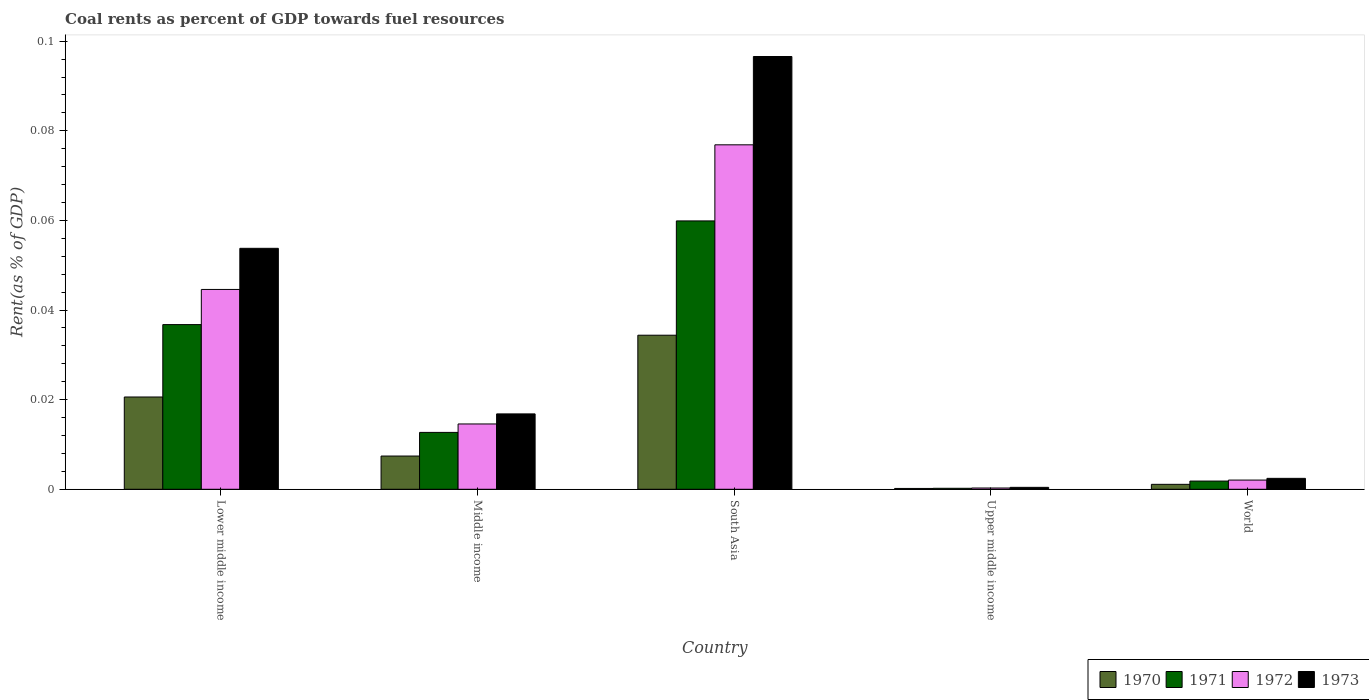How many different coloured bars are there?
Your answer should be very brief. 4. How many groups of bars are there?
Provide a succinct answer. 5. Are the number of bars per tick equal to the number of legend labels?
Offer a terse response. Yes. How many bars are there on the 4th tick from the right?
Make the answer very short. 4. What is the coal rent in 1972 in South Asia?
Provide a succinct answer. 0.08. Across all countries, what is the maximum coal rent in 1973?
Offer a very short reply. 0.1. Across all countries, what is the minimum coal rent in 1970?
Offer a terse response. 0. In which country was the coal rent in 1971 minimum?
Provide a succinct answer. Upper middle income. What is the total coal rent in 1971 in the graph?
Ensure brevity in your answer.  0.11. What is the difference between the coal rent in 1970 in Middle income and that in World?
Your answer should be compact. 0.01. What is the difference between the coal rent in 1971 in Upper middle income and the coal rent in 1973 in South Asia?
Provide a short and direct response. -0.1. What is the average coal rent in 1972 per country?
Offer a very short reply. 0.03. What is the difference between the coal rent of/in 1972 and coal rent of/in 1973 in Lower middle income?
Make the answer very short. -0.01. In how many countries, is the coal rent in 1973 greater than 0.08 %?
Make the answer very short. 1. What is the ratio of the coal rent in 1973 in Upper middle income to that in World?
Ensure brevity in your answer.  0.18. Is the coal rent in 1971 in Lower middle income less than that in Middle income?
Your answer should be very brief. No. What is the difference between the highest and the second highest coal rent in 1970?
Offer a very short reply. 0.01. What is the difference between the highest and the lowest coal rent in 1972?
Your answer should be very brief. 0.08. In how many countries, is the coal rent in 1970 greater than the average coal rent in 1970 taken over all countries?
Give a very brief answer. 2. Is it the case that in every country, the sum of the coal rent in 1971 and coal rent in 1973 is greater than the sum of coal rent in 1970 and coal rent in 1972?
Give a very brief answer. No. What does the 1st bar from the left in Lower middle income represents?
Keep it short and to the point. 1970. What does the 1st bar from the right in Upper middle income represents?
Your response must be concise. 1973. Where does the legend appear in the graph?
Provide a succinct answer. Bottom right. How many legend labels are there?
Keep it short and to the point. 4. What is the title of the graph?
Your answer should be very brief. Coal rents as percent of GDP towards fuel resources. Does "2003" appear as one of the legend labels in the graph?
Ensure brevity in your answer.  No. What is the label or title of the Y-axis?
Give a very brief answer. Rent(as % of GDP). What is the Rent(as % of GDP) in 1970 in Lower middle income?
Keep it short and to the point. 0.02. What is the Rent(as % of GDP) in 1971 in Lower middle income?
Provide a short and direct response. 0.04. What is the Rent(as % of GDP) in 1972 in Lower middle income?
Offer a very short reply. 0.04. What is the Rent(as % of GDP) in 1973 in Lower middle income?
Offer a very short reply. 0.05. What is the Rent(as % of GDP) in 1970 in Middle income?
Offer a very short reply. 0.01. What is the Rent(as % of GDP) in 1971 in Middle income?
Keep it short and to the point. 0.01. What is the Rent(as % of GDP) of 1972 in Middle income?
Keep it short and to the point. 0.01. What is the Rent(as % of GDP) in 1973 in Middle income?
Your answer should be compact. 0.02. What is the Rent(as % of GDP) of 1970 in South Asia?
Your answer should be compact. 0.03. What is the Rent(as % of GDP) of 1971 in South Asia?
Offer a terse response. 0.06. What is the Rent(as % of GDP) of 1972 in South Asia?
Give a very brief answer. 0.08. What is the Rent(as % of GDP) in 1973 in South Asia?
Make the answer very short. 0.1. What is the Rent(as % of GDP) in 1970 in Upper middle income?
Your response must be concise. 0. What is the Rent(as % of GDP) in 1971 in Upper middle income?
Offer a very short reply. 0. What is the Rent(as % of GDP) of 1972 in Upper middle income?
Provide a short and direct response. 0. What is the Rent(as % of GDP) of 1973 in Upper middle income?
Your answer should be very brief. 0. What is the Rent(as % of GDP) of 1970 in World?
Offer a very short reply. 0. What is the Rent(as % of GDP) in 1971 in World?
Your response must be concise. 0. What is the Rent(as % of GDP) in 1972 in World?
Make the answer very short. 0. What is the Rent(as % of GDP) of 1973 in World?
Offer a terse response. 0. Across all countries, what is the maximum Rent(as % of GDP) of 1970?
Your answer should be very brief. 0.03. Across all countries, what is the maximum Rent(as % of GDP) in 1971?
Ensure brevity in your answer.  0.06. Across all countries, what is the maximum Rent(as % of GDP) of 1972?
Offer a very short reply. 0.08. Across all countries, what is the maximum Rent(as % of GDP) in 1973?
Make the answer very short. 0.1. Across all countries, what is the minimum Rent(as % of GDP) in 1970?
Keep it short and to the point. 0. Across all countries, what is the minimum Rent(as % of GDP) of 1971?
Provide a short and direct response. 0. Across all countries, what is the minimum Rent(as % of GDP) of 1972?
Provide a short and direct response. 0. Across all countries, what is the minimum Rent(as % of GDP) in 1973?
Your answer should be compact. 0. What is the total Rent(as % of GDP) of 1970 in the graph?
Make the answer very short. 0.06. What is the total Rent(as % of GDP) in 1971 in the graph?
Offer a terse response. 0.11. What is the total Rent(as % of GDP) of 1972 in the graph?
Keep it short and to the point. 0.14. What is the total Rent(as % of GDP) of 1973 in the graph?
Your answer should be compact. 0.17. What is the difference between the Rent(as % of GDP) of 1970 in Lower middle income and that in Middle income?
Your answer should be very brief. 0.01. What is the difference between the Rent(as % of GDP) in 1971 in Lower middle income and that in Middle income?
Offer a very short reply. 0.02. What is the difference between the Rent(as % of GDP) of 1973 in Lower middle income and that in Middle income?
Keep it short and to the point. 0.04. What is the difference between the Rent(as % of GDP) of 1970 in Lower middle income and that in South Asia?
Your answer should be compact. -0.01. What is the difference between the Rent(as % of GDP) in 1971 in Lower middle income and that in South Asia?
Your answer should be very brief. -0.02. What is the difference between the Rent(as % of GDP) of 1972 in Lower middle income and that in South Asia?
Your answer should be compact. -0.03. What is the difference between the Rent(as % of GDP) in 1973 in Lower middle income and that in South Asia?
Offer a terse response. -0.04. What is the difference between the Rent(as % of GDP) in 1970 in Lower middle income and that in Upper middle income?
Ensure brevity in your answer.  0.02. What is the difference between the Rent(as % of GDP) in 1971 in Lower middle income and that in Upper middle income?
Ensure brevity in your answer.  0.04. What is the difference between the Rent(as % of GDP) in 1972 in Lower middle income and that in Upper middle income?
Offer a very short reply. 0.04. What is the difference between the Rent(as % of GDP) in 1973 in Lower middle income and that in Upper middle income?
Make the answer very short. 0.05. What is the difference between the Rent(as % of GDP) in 1970 in Lower middle income and that in World?
Your response must be concise. 0.02. What is the difference between the Rent(as % of GDP) of 1971 in Lower middle income and that in World?
Your answer should be very brief. 0.03. What is the difference between the Rent(as % of GDP) of 1972 in Lower middle income and that in World?
Offer a very short reply. 0.04. What is the difference between the Rent(as % of GDP) of 1973 in Lower middle income and that in World?
Offer a very short reply. 0.05. What is the difference between the Rent(as % of GDP) of 1970 in Middle income and that in South Asia?
Your answer should be compact. -0.03. What is the difference between the Rent(as % of GDP) of 1971 in Middle income and that in South Asia?
Provide a succinct answer. -0.05. What is the difference between the Rent(as % of GDP) in 1972 in Middle income and that in South Asia?
Keep it short and to the point. -0.06. What is the difference between the Rent(as % of GDP) in 1973 in Middle income and that in South Asia?
Offer a very short reply. -0.08. What is the difference between the Rent(as % of GDP) of 1970 in Middle income and that in Upper middle income?
Offer a terse response. 0.01. What is the difference between the Rent(as % of GDP) of 1971 in Middle income and that in Upper middle income?
Provide a short and direct response. 0.01. What is the difference between the Rent(as % of GDP) of 1972 in Middle income and that in Upper middle income?
Make the answer very short. 0.01. What is the difference between the Rent(as % of GDP) of 1973 in Middle income and that in Upper middle income?
Your answer should be very brief. 0.02. What is the difference between the Rent(as % of GDP) of 1970 in Middle income and that in World?
Ensure brevity in your answer.  0.01. What is the difference between the Rent(as % of GDP) in 1971 in Middle income and that in World?
Offer a terse response. 0.01. What is the difference between the Rent(as % of GDP) in 1972 in Middle income and that in World?
Make the answer very short. 0.01. What is the difference between the Rent(as % of GDP) in 1973 in Middle income and that in World?
Offer a very short reply. 0.01. What is the difference between the Rent(as % of GDP) in 1970 in South Asia and that in Upper middle income?
Your answer should be very brief. 0.03. What is the difference between the Rent(as % of GDP) in 1971 in South Asia and that in Upper middle income?
Keep it short and to the point. 0.06. What is the difference between the Rent(as % of GDP) of 1972 in South Asia and that in Upper middle income?
Provide a short and direct response. 0.08. What is the difference between the Rent(as % of GDP) of 1973 in South Asia and that in Upper middle income?
Provide a succinct answer. 0.1. What is the difference between the Rent(as % of GDP) in 1971 in South Asia and that in World?
Provide a succinct answer. 0.06. What is the difference between the Rent(as % of GDP) in 1972 in South Asia and that in World?
Your answer should be compact. 0.07. What is the difference between the Rent(as % of GDP) of 1973 in South Asia and that in World?
Provide a succinct answer. 0.09. What is the difference between the Rent(as % of GDP) of 1970 in Upper middle income and that in World?
Offer a very short reply. -0. What is the difference between the Rent(as % of GDP) in 1971 in Upper middle income and that in World?
Give a very brief answer. -0. What is the difference between the Rent(as % of GDP) of 1972 in Upper middle income and that in World?
Your answer should be very brief. -0. What is the difference between the Rent(as % of GDP) of 1973 in Upper middle income and that in World?
Keep it short and to the point. -0. What is the difference between the Rent(as % of GDP) in 1970 in Lower middle income and the Rent(as % of GDP) in 1971 in Middle income?
Your answer should be very brief. 0.01. What is the difference between the Rent(as % of GDP) of 1970 in Lower middle income and the Rent(as % of GDP) of 1972 in Middle income?
Your response must be concise. 0.01. What is the difference between the Rent(as % of GDP) in 1970 in Lower middle income and the Rent(as % of GDP) in 1973 in Middle income?
Ensure brevity in your answer.  0. What is the difference between the Rent(as % of GDP) of 1971 in Lower middle income and the Rent(as % of GDP) of 1972 in Middle income?
Your answer should be compact. 0.02. What is the difference between the Rent(as % of GDP) in 1971 in Lower middle income and the Rent(as % of GDP) in 1973 in Middle income?
Your answer should be compact. 0.02. What is the difference between the Rent(as % of GDP) of 1972 in Lower middle income and the Rent(as % of GDP) of 1973 in Middle income?
Your answer should be very brief. 0.03. What is the difference between the Rent(as % of GDP) in 1970 in Lower middle income and the Rent(as % of GDP) in 1971 in South Asia?
Ensure brevity in your answer.  -0.04. What is the difference between the Rent(as % of GDP) of 1970 in Lower middle income and the Rent(as % of GDP) of 1972 in South Asia?
Offer a terse response. -0.06. What is the difference between the Rent(as % of GDP) in 1970 in Lower middle income and the Rent(as % of GDP) in 1973 in South Asia?
Ensure brevity in your answer.  -0.08. What is the difference between the Rent(as % of GDP) of 1971 in Lower middle income and the Rent(as % of GDP) of 1972 in South Asia?
Your answer should be very brief. -0.04. What is the difference between the Rent(as % of GDP) in 1971 in Lower middle income and the Rent(as % of GDP) in 1973 in South Asia?
Ensure brevity in your answer.  -0.06. What is the difference between the Rent(as % of GDP) of 1972 in Lower middle income and the Rent(as % of GDP) of 1973 in South Asia?
Make the answer very short. -0.05. What is the difference between the Rent(as % of GDP) of 1970 in Lower middle income and the Rent(as % of GDP) of 1971 in Upper middle income?
Offer a very short reply. 0.02. What is the difference between the Rent(as % of GDP) in 1970 in Lower middle income and the Rent(as % of GDP) in 1972 in Upper middle income?
Offer a terse response. 0.02. What is the difference between the Rent(as % of GDP) of 1970 in Lower middle income and the Rent(as % of GDP) of 1973 in Upper middle income?
Give a very brief answer. 0.02. What is the difference between the Rent(as % of GDP) in 1971 in Lower middle income and the Rent(as % of GDP) in 1972 in Upper middle income?
Give a very brief answer. 0.04. What is the difference between the Rent(as % of GDP) in 1971 in Lower middle income and the Rent(as % of GDP) in 1973 in Upper middle income?
Offer a terse response. 0.04. What is the difference between the Rent(as % of GDP) of 1972 in Lower middle income and the Rent(as % of GDP) of 1973 in Upper middle income?
Give a very brief answer. 0.04. What is the difference between the Rent(as % of GDP) of 1970 in Lower middle income and the Rent(as % of GDP) of 1971 in World?
Your answer should be compact. 0.02. What is the difference between the Rent(as % of GDP) of 1970 in Lower middle income and the Rent(as % of GDP) of 1972 in World?
Your response must be concise. 0.02. What is the difference between the Rent(as % of GDP) in 1970 in Lower middle income and the Rent(as % of GDP) in 1973 in World?
Your answer should be compact. 0.02. What is the difference between the Rent(as % of GDP) of 1971 in Lower middle income and the Rent(as % of GDP) of 1972 in World?
Keep it short and to the point. 0.03. What is the difference between the Rent(as % of GDP) in 1971 in Lower middle income and the Rent(as % of GDP) in 1973 in World?
Your answer should be compact. 0.03. What is the difference between the Rent(as % of GDP) of 1972 in Lower middle income and the Rent(as % of GDP) of 1973 in World?
Make the answer very short. 0.04. What is the difference between the Rent(as % of GDP) in 1970 in Middle income and the Rent(as % of GDP) in 1971 in South Asia?
Offer a terse response. -0.05. What is the difference between the Rent(as % of GDP) in 1970 in Middle income and the Rent(as % of GDP) in 1972 in South Asia?
Make the answer very short. -0.07. What is the difference between the Rent(as % of GDP) of 1970 in Middle income and the Rent(as % of GDP) of 1973 in South Asia?
Provide a succinct answer. -0.09. What is the difference between the Rent(as % of GDP) of 1971 in Middle income and the Rent(as % of GDP) of 1972 in South Asia?
Your answer should be compact. -0.06. What is the difference between the Rent(as % of GDP) in 1971 in Middle income and the Rent(as % of GDP) in 1973 in South Asia?
Give a very brief answer. -0.08. What is the difference between the Rent(as % of GDP) in 1972 in Middle income and the Rent(as % of GDP) in 1973 in South Asia?
Offer a very short reply. -0.08. What is the difference between the Rent(as % of GDP) of 1970 in Middle income and the Rent(as % of GDP) of 1971 in Upper middle income?
Ensure brevity in your answer.  0.01. What is the difference between the Rent(as % of GDP) in 1970 in Middle income and the Rent(as % of GDP) in 1972 in Upper middle income?
Your answer should be compact. 0.01. What is the difference between the Rent(as % of GDP) in 1970 in Middle income and the Rent(as % of GDP) in 1973 in Upper middle income?
Provide a short and direct response. 0.01. What is the difference between the Rent(as % of GDP) in 1971 in Middle income and the Rent(as % of GDP) in 1972 in Upper middle income?
Your response must be concise. 0.01. What is the difference between the Rent(as % of GDP) in 1971 in Middle income and the Rent(as % of GDP) in 1973 in Upper middle income?
Make the answer very short. 0.01. What is the difference between the Rent(as % of GDP) of 1972 in Middle income and the Rent(as % of GDP) of 1973 in Upper middle income?
Offer a terse response. 0.01. What is the difference between the Rent(as % of GDP) in 1970 in Middle income and the Rent(as % of GDP) in 1971 in World?
Make the answer very short. 0.01. What is the difference between the Rent(as % of GDP) of 1970 in Middle income and the Rent(as % of GDP) of 1972 in World?
Provide a short and direct response. 0.01. What is the difference between the Rent(as % of GDP) of 1970 in Middle income and the Rent(as % of GDP) of 1973 in World?
Make the answer very short. 0.01. What is the difference between the Rent(as % of GDP) in 1971 in Middle income and the Rent(as % of GDP) in 1972 in World?
Your answer should be compact. 0.01. What is the difference between the Rent(as % of GDP) in 1971 in Middle income and the Rent(as % of GDP) in 1973 in World?
Offer a terse response. 0.01. What is the difference between the Rent(as % of GDP) in 1972 in Middle income and the Rent(as % of GDP) in 1973 in World?
Give a very brief answer. 0.01. What is the difference between the Rent(as % of GDP) of 1970 in South Asia and the Rent(as % of GDP) of 1971 in Upper middle income?
Offer a terse response. 0.03. What is the difference between the Rent(as % of GDP) of 1970 in South Asia and the Rent(as % of GDP) of 1972 in Upper middle income?
Offer a very short reply. 0.03. What is the difference between the Rent(as % of GDP) of 1970 in South Asia and the Rent(as % of GDP) of 1973 in Upper middle income?
Your response must be concise. 0.03. What is the difference between the Rent(as % of GDP) of 1971 in South Asia and the Rent(as % of GDP) of 1972 in Upper middle income?
Your response must be concise. 0.06. What is the difference between the Rent(as % of GDP) in 1971 in South Asia and the Rent(as % of GDP) in 1973 in Upper middle income?
Give a very brief answer. 0.06. What is the difference between the Rent(as % of GDP) in 1972 in South Asia and the Rent(as % of GDP) in 1973 in Upper middle income?
Give a very brief answer. 0.08. What is the difference between the Rent(as % of GDP) in 1970 in South Asia and the Rent(as % of GDP) in 1971 in World?
Make the answer very short. 0.03. What is the difference between the Rent(as % of GDP) of 1970 in South Asia and the Rent(as % of GDP) of 1972 in World?
Your response must be concise. 0.03. What is the difference between the Rent(as % of GDP) of 1970 in South Asia and the Rent(as % of GDP) of 1973 in World?
Ensure brevity in your answer.  0.03. What is the difference between the Rent(as % of GDP) in 1971 in South Asia and the Rent(as % of GDP) in 1972 in World?
Make the answer very short. 0.06. What is the difference between the Rent(as % of GDP) in 1971 in South Asia and the Rent(as % of GDP) in 1973 in World?
Offer a very short reply. 0.06. What is the difference between the Rent(as % of GDP) of 1972 in South Asia and the Rent(as % of GDP) of 1973 in World?
Your response must be concise. 0.07. What is the difference between the Rent(as % of GDP) of 1970 in Upper middle income and the Rent(as % of GDP) of 1971 in World?
Give a very brief answer. -0. What is the difference between the Rent(as % of GDP) in 1970 in Upper middle income and the Rent(as % of GDP) in 1972 in World?
Offer a terse response. -0. What is the difference between the Rent(as % of GDP) of 1970 in Upper middle income and the Rent(as % of GDP) of 1973 in World?
Offer a very short reply. -0. What is the difference between the Rent(as % of GDP) of 1971 in Upper middle income and the Rent(as % of GDP) of 1972 in World?
Your response must be concise. -0. What is the difference between the Rent(as % of GDP) of 1971 in Upper middle income and the Rent(as % of GDP) of 1973 in World?
Offer a terse response. -0. What is the difference between the Rent(as % of GDP) in 1972 in Upper middle income and the Rent(as % of GDP) in 1973 in World?
Make the answer very short. -0. What is the average Rent(as % of GDP) in 1970 per country?
Offer a very short reply. 0.01. What is the average Rent(as % of GDP) in 1971 per country?
Keep it short and to the point. 0.02. What is the average Rent(as % of GDP) in 1972 per country?
Your response must be concise. 0.03. What is the average Rent(as % of GDP) in 1973 per country?
Your response must be concise. 0.03. What is the difference between the Rent(as % of GDP) of 1970 and Rent(as % of GDP) of 1971 in Lower middle income?
Make the answer very short. -0.02. What is the difference between the Rent(as % of GDP) of 1970 and Rent(as % of GDP) of 1972 in Lower middle income?
Ensure brevity in your answer.  -0.02. What is the difference between the Rent(as % of GDP) of 1970 and Rent(as % of GDP) of 1973 in Lower middle income?
Provide a succinct answer. -0.03. What is the difference between the Rent(as % of GDP) of 1971 and Rent(as % of GDP) of 1972 in Lower middle income?
Provide a succinct answer. -0.01. What is the difference between the Rent(as % of GDP) in 1971 and Rent(as % of GDP) in 1973 in Lower middle income?
Keep it short and to the point. -0.02. What is the difference between the Rent(as % of GDP) in 1972 and Rent(as % of GDP) in 1973 in Lower middle income?
Your response must be concise. -0.01. What is the difference between the Rent(as % of GDP) of 1970 and Rent(as % of GDP) of 1971 in Middle income?
Keep it short and to the point. -0.01. What is the difference between the Rent(as % of GDP) of 1970 and Rent(as % of GDP) of 1972 in Middle income?
Offer a very short reply. -0.01. What is the difference between the Rent(as % of GDP) in 1970 and Rent(as % of GDP) in 1973 in Middle income?
Provide a succinct answer. -0.01. What is the difference between the Rent(as % of GDP) in 1971 and Rent(as % of GDP) in 1972 in Middle income?
Your answer should be compact. -0. What is the difference between the Rent(as % of GDP) of 1971 and Rent(as % of GDP) of 1973 in Middle income?
Ensure brevity in your answer.  -0. What is the difference between the Rent(as % of GDP) of 1972 and Rent(as % of GDP) of 1973 in Middle income?
Your answer should be compact. -0. What is the difference between the Rent(as % of GDP) of 1970 and Rent(as % of GDP) of 1971 in South Asia?
Your answer should be compact. -0.03. What is the difference between the Rent(as % of GDP) of 1970 and Rent(as % of GDP) of 1972 in South Asia?
Provide a succinct answer. -0.04. What is the difference between the Rent(as % of GDP) of 1970 and Rent(as % of GDP) of 1973 in South Asia?
Your answer should be compact. -0.06. What is the difference between the Rent(as % of GDP) of 1971 and Rent(as % of GDP) of 1972 in South Asia?
Offer a very short reply. -0.02. What is the difference between the Rent(as % of GDP) in 1971 and Rent(as % of GDP) in 1973 in South Asia?
Offer a very short reply. -0.04. What is the difference between the Rent(as % of GDP) of 1972 and Rent(as % of GDP) of 1973 in South Asia?
Provide a succinct answer. -0.02. What is the difference between the Rent(as % of GDP) of 1970 and Rent(as % of GDP) of 1971 in Upper middle income?
Make the answer very short. -0. What is the difference between the Rent(as % of GDP) of 1970 and Rent(as % of GDP) of 1972 in Upper middle income?
Your answer should be compact. -0. What is the difference between the Rent(as % of GDP) of 1970 and Rent(as % of GDP) of 1973 in Upper middle income?
Provide a succinct answer. -0. What is the difference between the Rent(as % of GDP) of 1971 and Rent(as % of GDP) of 1972 in Upper middle income?
Offer a terse response. -0. What is the difference between the Rent(as % of GDP) in 1971 and Rent(as % of GDP) in 1973 in Upper middle income?
Ensure brevity in your answer.  -0. What is the difference between the Rent(as % of GDP) of 1972 and Rent(as % of GDP) of 1973 in Upper middle income?
Your answer should be compact. -0. What is the difference between the Rent(as % of GDP) of 1970 and Rent(as % of GDP) of 1971 in World?
Ensure brevity in your answer.  -0. What is the difference between the Rent(as % of GDP) of 1970 and Rent(as % of GDP) of 1972 in World?
Your answer should be compact. -0. What is the difference between the Rent(as % of GDP) in 1970 and Rent(as % of GDP) in 1973 in World?
Ensure brevity in your answer.  -0. What is the difference between the Rent(as % of GDP) in 1971 and Rent(as % of GDP) in 1972 in World?
Your answer should be very brief. -0. What is the difference between the Rent(as % of GDP) of 1971 and Rent(as % of GDP) of 1973 in World?
Ensure brevity in your answer.  -0. What is the difference between the Rent(as % of GDP) of 1972 and Rent(as % of GDP) of 1973 in World?
Ensure brevity in your answer.  -0. What is the ratio of the Rent(as % of GDP) of 1970 in Lower middle income to that in Middle income?
Ensure brevity in your answer.  2.78. What is the ratio of the Rent(as % of GDP) of 1971 in Lower middle income to that in Middle income?
Provide a short and direct response. 2.9. What is the ratio of the Rent(as % of GDP) of 1972 in Lower middle income to that in Middle income?
Provide a short and direct response. 3.06. What is the ratio of the Rent(as % of GDP) in 1973 in Lower middle income to that in Middle income?
Your answer should be very brief. 3.2. What is the ratio of the Rent(as % of GDP) of 1970 in Lower middle income to that in South Asia?
Provide a succinct answer. 0.6. What is the ratio of the Rent(as % of GDP) in 1971 in Lower middle income to that in South Asia?
Keep it short and to the point. 0.61. What is the ratio of the Rent(as % of GDP) in 1972 in Lower middle income to that in South Asia?
Your response must be concise. 0.58. What is the ratio of the Rent(as % of GDP) of 1973 in Lower middle income to that in South Asia?
Ensure brevity in your answer.  0.56. What is the ratio of the Rent(as % of GDP) of 1970 in Lower middle income to that in Upper middle income?
Ensure brevity in your answer.  112.03. What is the ratio of the Rent(as % of GDP) of 1971 in Lower middle income to that in Upper middle income?
Your response must be concise. 167.98. What is the ratio of the Rent(as % of GDP) of 1972 in Lower middle income to that in Upper middle income?
Provide a short and direct response. 156.82. What is the ratio of the Rent(as % of GDP) of 1973 in Lower middle income to that in Upper middle income?
Your response must be concise. 124.82. What is the ratio of the Rent(as % of GDP) in 1970 in Lower middle income to that in World?
Make the answer very short. 18.71. What is the ratio of the Rent(as % of GDP) of 1971 in Lower middle income to that in World?
Make the answer very short. 20.06. What is the ratio of the Rent(as % of GDP) of 1972 in Lower middle income to that in World?
Provide a succinct answer. 21.7. What is the ratio of the Rent(as % of GDP) of 1973 in Lower middle income to that in World?
Give a very brief answer. 22.07. What is the ratio of the Rent(as % of GDP) in 1970 in Middle income to that in South Asia?
Your answer should be very brief. 0.22. What is the ratio of the Rent(as % of GDP) in 1971 in Middle income to that in South Asia?
Your response must be concise. 0.21. What is the ratio of the Rent(as % of GDP) of 1972 in Middle income to that in South Asia?
Offer a very short reply. 0.19. What is the ratio of the Rent(as % of GDP) of 1973 in Middle income to that in South Asia?
Keep it short and to the point. 0.17. What is the ratio of the Rent(as % of GDP) in 1970 in Middle income to that in Upper middle income?
Provide a short and direct response. 40.36. What is the ratio of the Rent(as % of GDP) in 1971 in Middle income to that in Upper middle income?
Keep it short and to the point. 58.01. What is the ratio of the Rent(as % of GDP) in 1972 in Middle income to that in Upper middle income?
Provide a short and direct response. 51.25. What is the ratio of the Rent(as % of GDP) in 1973 in Middle income to that in Upper middle income?
Provide a succinct answer. 39.04. What is the ratio of the Rent(as % of GDP) in 1970 in Middle income to that in World?
Your answer should be very brief. 6.74. What is the ratio of the Rent(as % of GDP) of 1971 in Middle income to that in World?
Offer a very short reply. 6.93. What is the ratio of the Rent(as % of GDP) of 1972 in Middle income to that in World?
Provide a succinct answer. 7.09. What is the ratio of the Rent(as % of GDP) of 1973 in Middle income to that in World?
Provide a short and direct response. 6.91. What is the ratio of the Rent(as % of GDP) of 1970 in South Asia to that in Upper middle income?
Your response must be concise. 187.05. What is the ratio of the Rent(as % of GDP) of 1971 in South Asia to that in Upper middle income?
Give a very brief answer. 273.74. What is the ratio of the Rent(as % of GDP) in 1972 in South Asia to that in Upper middle income?
Offer a very short reply. 270.32. What is the ratio of the Rent(as % of GDP) of 1973 in South Asia to that in Upper middle income?
Provide a succinct answer. 224.18. What is the ratio of the Rent(as % of GDP) in 1970 in South Asia to that in World?
Give a very brief answer. 31.24. What is the ratio of the Rent(as % of GDP) in 1971 in South Asia to that in World?
Ensure brevity in your answer.  32.69. What is the ratio of the Rent(as % of GDP) in 1972 in South Asia to that in World?
Ensure brevity in your answer.  37.41. What is the ratio of the Rent(as % of GDP) in 1973 in South Asia to that in World?
Provide a short and direct response. 39.65. What is the ratio of the Rent(as % of GDP) of 1970 in Upper middle income to that in World?
Your answer should be compact. 0.17. What is the ratio of the Rent(as % of GDP) in 1971 in Upper middle income to that in World?
Offer a terse response. 0.12. What is the ratio of the Rent(as % of GDP) of 1972 in Upper middle income to that in World?
Offer a terse response. 0.14. What is the ratio of the Rent(as % of GDP) of 1973 in Upper middle income to that in World?
Offer a terse response. 0.18. What is the difference between the highest and the second highest Rent(as % of GDP) of 1970?
Ensure brevity in your answer.  0.01. What is the difference between the highest and the second highest Rent(as % of GDP) in 1971?
Ensure brevity in your answer.  0.02. What is the difference between the highest and the second highest Rent(as % of GDP) of 1972?
Keep it short and to the point. 0.03. What is the difference between the highest and the second highest Rent(as % of GDP) in 1973?
Give a very brief answer. 0.04. What is the difference between the highest and the lowest Rent(as % of GDP) of 1970?
Give a very brief answer. 0.03. What is the difference between the highest and the lowest Rent(as % of GDP) in 1971?
Provide a short and direct response. 0.06. What is the difference between the highest and the lowest Rent(as % of GDP) of 1972?
Provide a succinct answer. 0.08. What is the difference between the highest and the lowest Rent(as % of GDP) of 1973?
Provide a short and direct response. 0.1. 